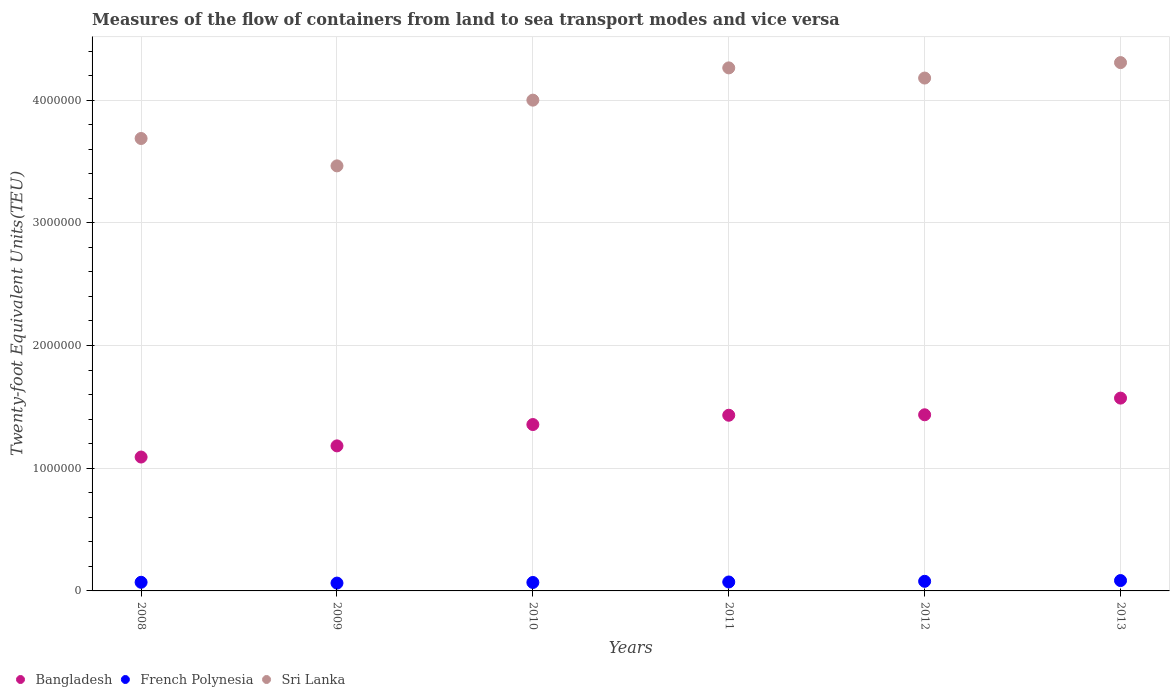What is the container port traffic in Sri Lanka in 2013?
Your answer should be compact. 4.31e+06. Across all years, what is the maximum container port traffic in French Polynesia?
Your answer should be very brief. 8.45e+04. Across all years, what is the minimum container port traffic in French Polynesia?
Make the answer very short. 6.38e+04. What is the total container port traffic in French Polynesia in the graph?
Ensure brevity in your answer.  4.39e+05. What is the difference between the container port traffic in French Polynesia in 2009 and that in 2013?
Keep it short and to the point. -2.07e+04. What is the difference between the container port traffic in French Polynesia in 2013 and the container port traffic in Bangladesh in 2010?
Offer a terse response. -1.27e+06. What is the average container port traffic in French Polynesia per year?
Ensure brevity in your answer.  7.31e+04. In the year 2012, what is the difference between the container port traffic in French Polynesia and container port traffic in Sri Lanka?
Offer a terse response. -4.10e+06. What is the ratio of the container port traffic in French Polynesia in 2008 to that in 2011?
Provide a succinct answer. 0.97. Is the difference between the container port traffic in French Polynesia in 2008 and 2013 greater than the difference between the container port traffic in Sri Lanka in 2008 and 2013?
Provide a short and direct response. Yes. What is the difference between the highest and the second highest container port traffic in French Polynesia?
Your answer should be very brief. 6183.87. What is the difference between the highest and the lowest container port traffic in French Polynesia?
Your response must be concise. 2.07e+04. In how many years, is the container port traffic in French Polynesia greater than the average container port traffic in French Polynesia taken over all years?
Offer a very short reply. 2. Is it the case that in every year, the sum of the container port traffic in French Polynesia and container port traffic in Sri Lanka  is greater than the container port traffic in Bangladesh?
Your response must be concise. Yes. Does the container port traffic in French Polynesia monotonically increase over the years?
Give a very brief answer. No. Is the container port traffic in French Polynesia strictly greater than the container port traffic in Sri Lanka over the years?
Provide a succinct answer. No. How many dotlines are there?
Ensure brevity in your answer.  3. Does the graph contain any zero values?
Your answer should be very brief. No. How many legend labels are there?
Your answer should be very brief. 3. What is the title of the graph?
Your answer should be compact. Measures of the flow of containers from land to sea transport modes and vice versa. Does "Sweden" appear as one of the legend labels in the graph?
Your answer should be compact. No. What is the label or title of the Y-axis?
Keep it short and to the point. Twenty-foot Equivalent Units(TEU). What is the Twenty-foot Equivalent Units(TEU) of Bangladesh in 2008?
Make the answer very short. 1.09e+06. What is the Twenty-foot Equivalent Units(TEU) in French Polynesia in 2008?
Offer a terse response. 7.03e+04. What is the Twenty-foot Equivalent Units(TEU) in Sri Lanka in 2008?
Make the answer very short. 3.69e+06. What is the Twenty-foot Equivalent Units(TEU) in Bangladesh in 2009?
Provide a succinct answer. 1.18e+06. What is the Twenty-foot Equivalent Units(TEU) of French Polynesia in 2009?
Keep it short and to the point. 6.38e+04. What is the Twenty-foot Equivalent Units(TEU) in Sri Lanka in 2009?
Give a very brief answer. 3.46e+06. What is the Twenty-foot Equivalent Units(TEU) in Bangladesh in 2010?
Ensure brevity in your answer.  1.36e+06. What is the Twenty-foot Equivalent Units(TEU) in French Polynesia in 2010?
Give a very brief answer. 6.89e+04. What is the Twenty-foot Equivalent Units(TEU) in Bangladesh in 2011?
Give a very brief answer. 1.43e+06. What is the Twenty-foot Equivalent Units(TEU) in French Polynesia in 2011?
Offer a very short reply. 7.28e+04. What is the Twenty-foot Equivalent Units(TEU) of Sri Lanka in 2011?
Your response must be concise. 4.26e+06. What is the Twenty-foot Equivalent Units(TEU) in Bangladesh in 2012?
Keep it short and to the point. 1.44e+06. What is the Twenty-foot Equivalent Units(TEU) in French Polynesia in 2012?
Your answer should be compact. 7.83e+04. What is the Twenty-foot Equivalent Units(TEU) in Sri Lanka in 2012?
Your response must be concise. 4.18e+06. What is the Twenty-foot Equivalent Units(TEU) of Bangladesh in 2013?
Offer a very short reply. 1.57e+06. What is the Twenty-foot Equivalent Units(TEU) in French Polynesia in 2013?
Your answer should be very brief. 8.45e+04. What is the Twenty-foot Equivalent Units(TEU) in Sri Lanka in 2013?
Your response must be concise. 4.31e+06. Across all years, what is the maximum Twenty-foot Equivalent Units(TEU) of Bangladesh?
Offer a terse response. 1.57e+06. Across all years, what is the maximum Twenty-foot Equivalent Units(TEU) of French Polynesia?
Offer a terse response. 8.45e+04. Across all years, what is the maximum Twenty-foot Equivalent Units(TEU) of Sri Lanka?
Your answer should be very brief. 4.31e+06. Across all years, what is the minimum Twenty-foot Equivalent Units(TEU) of Bangladesh?
Your answer should be very brief. 1.09e+06. Across all years, what is the minimum Twenty-foot Equivalent Units(TEU) in French Polynesia?
Your response must be concise. 6.38e+04. Across all years, what is the minimum Twenty-foot Equivalent Units(TEU) of Sri Lanka?
Your answer should be compact. 3.46e+06. What is the total Twenty-foot Equivalent Units(TEU) of Bangladesh in the graph?
Provide a succinct answer. 8.07e+06. What is the total Twenty-foot Equivalent Units(TEU) of French Polynesia in the graph?
Offer a terse response. 4.39e+05. What is the total Twenty-foot Equivalent Units(TEU) in Sri Lanka in the graph?
Ensure brevity in your answer.  2.39e+07. What is the difference between the Twenty-foot Equivalent Units(TEU) of Bangladesh in 2008 and that in 2009?
Your response must be concise. -9.09e+04. What is the difference between the Twenty-foot Equivalent Units(TEU) of French Polynesia in 2008 and that in 2009?
Make the answer very short. 6529. What is the difference between the Twenty-foot Equivalent Units(TEU) of Sri Lanka in 2008 and that in 2009?
Make the answer very short. 2.23e+05. What is the difference between the Twenty-foot Equivalent Units(TEU) in Bangladesh in 2008 and that in 2010?
Your answer should be very brief. -2.65e+05. What is the difference between the Twenty-foot Equivalent Units(TEU) in French Polynesia in 2008 and that in 2010?
Your response must be concise. 1447. What is the difference between the Twenty-foot Equivalent Units(TEU) of Sri Lanka in 2008 and that in 2010?
Your answer should be compact. -3.13e+05. What is the difference between the Twenty-foot Equivalent Units(TEU) in Bangladesh in 2008 and that in 2011?
Offer a terse response. -3.41e+05. What is the difference between the Twenty-foot Equivalent Units(TEU) of French Polynesia in 2008 and that in 2011?
Offer a terse response. -2479.67. What is the difference between the Twenty-foot Equivalent Units(TEU) of Sri Lanka in 2008 and that in 2011?
Your answer should be very brief. -5.75e+05. What is the difference between the Twenty-foot Equivalent Units(TEU) of Bangladesh in 2008 and that in 2012?
Keep it short and to the point. -3.44e+05. What is the difference between the Twenty-foot Equivalent Units(TEU) in French Polynesia in 2008 and that in 2012?
Make the answer very short. -7940.85. What is the difference between the Twenty-foot Equivalent Units(TEU) in Sri Lanka in 2008 and that in 2012?
Your response must be concise. -4.93e+05. What is the difference between the Twenty-foot Equivalent Units(TEU) in Bangladesh in 2008 and that in 2013?
Provide a short and direct response. -4.80e+05. What is the difference between the Twenty-foot Equivalent Units(TEU) of French Polynesia in 2008 and that in 2013?
Your answer should be very brief. -1.41e+04. What is the difference between the Twenty-foot Equivalent Units(TEU) in Sri Lanka in 2008 and that in 2013?
Your response must be concise. -6.19e+05. What is the difference between the Twenty-foot Equivalent Units(TEU) in Bangladesh in 2009 and that in 2010?
Make the answer very short. -1.74e+05. What is the difference between the Twenty-foot Equivalent Units(TEU) in French Polynesia in 2009 and that in 2010?
Offer a very short reply. -5082. What is the difference between the Twenty-foot Equivalent Units(TEU) in Sri Lanka in 2009 and that in 2010?
Ensure brevity in your answer.  -5.36e+05. What is the difference between the Twenty-foot Equivalent Units(TEU) of Bangladesh in 2009 and that in 2011?
Ensure brevity in your answer.  -2.50e+05. What is the difference between the Twenty-foot Equivalent Units(TEU) of French Polynesia in 2009 and that in 2011?
Your answer should be compact. -9008.67. What is the difference between the Twenty-foot Equivalent Units(TEU) in Sri Lanka in 2009 and that in 2011?
Your answer should be compact. -7.99e+05. What is the difference between the Twenty-foot Equivalent Units(TEU) in Bangladesh in 2009 and that in 2012?
Give a very brief answer. -2.53e+05. What is the difference between the Twenty-foot Equivalent Units(TEU) in French Polynesia in 2009 and that in 2012?
Offer a terse response. -1.45e+04. What is the difference between the Twenty-foot Equivalent Units(TEU) in Sri Lanka in 2009 and that in 2012?
Your response must be concise. -7.16e+05. What is the difference between the Twenty-foot Equivalent Units(TEU) of Bangladesh in 2009 and that in 2013?
Offer a terse response. -3.89e+05. What is the difference between the Twenty-foot Equivalent Units(TEU) of French Polynesia in 2009 and that in 2013?
Your answer should be compact. -2.07e+04. What is the difference between the Twenty-foot Equivalent Units(TEU) of Sri Lanka in 2009 and that in 2013?
Make the answer very short. -8.42e+05. What is the difference between the Twenty-foot Equivalent Units(TEU) in Bangladesh in 2010 and that in 2011?
Give a very brief answer. -7.58e+04. What is the difference between the Twenty-foot Equivalent Units(TEU) in French Polynesia in 2010 and that in 2011?
Offer a very short reply. -3926.67. What is the difference between the Twenty-foot Equivalent Units(TEU) of Sri Lanka in 2010 and that in 2011?
Provide a succinct answer. -2.63e+05. What is the difference between the Twenty-foot Equivalent Units(TEU) of Bangladesh in 2010 and that in 2012?
Provide a short and direct response. -7.95e+04. What is the difference between the Twenty-foot Equivalent Units(TEU) of French Polynesia in 2010 and that in 2012?
Your response must be concise. -9387.85. What is the difference between the Twenty-foot Equivalent Units(TEU) in Sri Lanka in 2010 and that in 2012?
Your answer should be very brief. -1.80e+05. What is the difference between the Twenty-foot Equivalent Units(TEU) in Bangladesh in 2010 and that in 2013?
Provide a succinct answer. -2.15e+05. What is the difference between the Twenty-foot Equivalent Units(TEU) of French Polynesia in 2010 and that in 2013?
Give a very brief answer. -1.56e+04. What is the difference between the Twenty-foot Equivalent Units(TEU) of Sri Lanka in 2010 and that in 2013?
Offer a very short reply. -3.06e+05. What is the difference between the Twenty-foot Equivalent Units(TEU) of Bangladesh in 2011 and that in 2012?
Offer a very short reply. -3748.59. What is the difference between the Twenty-foot Equivalent Units(TEU) in French Polynesia in 2011 and that in 2012?
Provide a succinct answer. -5461.18. What is the difference between the Twenty-foot Equivalent Units(TEU) in Sri Lanka in 2011 and that in 2012?
Give a very brief answer. 8.29e+04. What is the difference between the Twenty-foot Equivalent Units(TEU) of Bangladesh in 2011 and that in 2013?
Offer a terse response. -1.40e+05. What is the difference between the Twenty-foot Equivalent Units(TEU) in French Polynesia in 2011 and that in 2013?
Ensure brevity in your answer.  -1.16e+04. What is the difference between the Twenty-foot Equivalent Units(TEU) of Sri Lanka in 2011 and that in 2013?
Offer a terse response. -4.31e+04. What is the difference between the Twenty-foot Equivalent Units(TEU) in Bangladesh in 2012 and that in 2013?
Offer a very short reply. -1.36e+05. What is the difference between the Twenty-foot Equivalent Units(TEU) in French Polynesia in 2012 and that in 2013?
Provide a succinct answer. -6183.87. What is the difference between the Twenty-foot Equivalent Units(TEU) in Sri Lanka in 2012 and that in 2013?
Your answer should be very brief. -1.26e+05. What is the difference between the Twenty-foot Equivalent Units(TEU) in Bangladesh in 2008 and the Twenty-foot Equivalent Units(TEU) in French Polynesia in 2009?
Provide a succinct answer. 1.03e+06. What is the difference between the Twenty-foot Equivalent Units(TEU) in Bangladesh in 2008 and the Twenty-foot Equivalent Units(TEU) in Sri Lanka in 2009?
Give a very brief answer. -2.37e+06. What is the difference between the Twenty-foot Equivalent Units(TEU) in French Polynesia in 2008 and the Twenty-foot Equivalent Units(TEU) in Sri Lanka in 2009?
Make the answer very short. -3.39e+06. What is the difference between the Twenty-foot Equivalent Units(TEU) of Bangladesh in 2008 and the Twenty-foot Equivalent Units(TEU) of French Polynesia in 2010?
Provide a short and direct response. 1.02e+06. What is the difference between the Twenty-foot Equivalent Units(TEU) in Bangladesh in 2008 and the Twenty-foot Equivalent Units(TEU) in Sri Lanka in 2010?
Provide a succinct answer. -2.91e+06. What is the difference between the Twenty-foot Equivalent Units(TEU) of French Polynesia in 2008 and the Twenty-foot Equivalent Units(TEU) of Sri Lanka in 2010?
Your response must be concise. -3.93e+06. What is the difference between the Twenty-foot Equivalent Units(TEU) of Bangladesh in 2008 and the Twenty-foot Equivalent Units(TEU) of French Polynesia in 2011?
Provide a short and direct response. 1.02e+06. What is the difference between the Twenty-foot Equivalent Units(TEU) of Bangladesh in 2008 and the Twenty-foot Equivalent Units(TEU) of Sri Lanka in 2011?
Provide a short and direct response. -3.17e+06. What is the difference between the Twenty-foot Equivalent Units(TEU) in French Polynesia in 2008 and the Twenty-foot Equivalent Units(TEU) in Sri Lanka in 2011?
Your answer should be very brief. -4.19e+06. What is the difference between the Twenty-foot Equivalent Units(TEU) in Bangladesh in 2008 and the Twenty-foot Equivalent Units(TEU) in French Polynesia in 2012?
Your answer should be very brief. 1.01e+06. What is the difference between the Twenty-foot Equivalent Units(TEU) of Bangladesh in 2008 and the Twenty-foot Equivalent Units(TEU) of Sri Lanka in 2012?
Your response must be concise. -3.09e+06. What is the difference between the Twenty-foot Equivalent Units(TEU) in French Polynesia in 2008 and the Twenty-foot Equivalent Units(TEU) in Sri Lanka in 2012?
Provide a short and direct response. -4.11e+06. What is the difference between the Twenty-foot Equivalent Units(TEU) in Bangladesh in 2008 and the Twenty-foot Equivalent Units(TEU) in French Polynesia in 2013?
Keep it short and to the point. 1.01e+06. What is the difference between the Twenty-foot Equivalent Units(TEU) in Bangladesh in 2008 and the Twenty-foot Equivalent Units(TEU) in Sri Lanka in 2013?
Make the answer very short. -3.21e+06. What is the difference between the Twenty-foot Equivalent Units(TEU) of French Polynesia in 2008 and the Twenty-foot Equivalent Units(TEU) of Sri Lanka in 2013?
Provide a short and direct response. -4.24e+06. What is the difference between the Twenty-foot Equivalent Units(TEU) of Bangladesh in 2009 and the Twenty-foot Equivalent Units(TEU) of French Polynesia in 2010?
Provide a short and direct response. 1.11e+06. What is the difference between the Twenty-foot Equivalent Units(TEU) in Bangladesh in 2009 and the Twenty-foot Equivalent Units(TEU) in Sri Lanka in 2010?
Ensure brevity in your answer.  -2.82e+06. What is the difference between the Twenty-foot Equivalent Units(TEU) of French Polynesia in 2009 and the Twenty-foot Equivalent Units(TEU) of Sri Lanka in 2010?
Offer a terse response. -3.94e+06. What is the difference between the Twenty-foot Equivalent Units(TEU) of Bangladesh in 2009 and the Twenty-foot Equivalent Units(TEU) of French Polynesia in 2011?
Your answer should be very brief. 1.11e+06. What is the difference between the Twenty-foot Equivalent Units(TEU) in Bangladesh in 2009 and the Twenty-foot Equivalent Units(TEU) in Sri Lanka in 2011?
Provide a succinct answer. -3.08e+06. What is the difference between the Twenty-foot Equivalent Units(TEU) of French Polynesia in 2009 and the Twenty-foot Equivalent Units(TEU) of Sri Lanka in 2011?
Offer a terse response. -4.20e+06. What is the difference between the Twenty-foot Equivalent Units(TEU) of Bangladesh in 2009 and the Twenty-foot Equivalent Units(TEU) of French Polynesia in 2012?
Offer a very short reply. 1.10e+06. What is the difference between the Twenty-foot Equivalent Units(TEU) of Bangladesh in 2009 and the Twenty-foot Equivalent Units(TEU) of Sri Lanka in 2012?
Provide a succinct answer. -3.00e+06. What is the difference between the Twenty-foot Equivalent Units(TEU) in French Polynesia in 2009 and the Twenty-foot Equivalent Units(TEU) in Sri Lanka in 2012?
Your answer should be very brief. -4.12e+06. What is the difference between the Twenty-foot Equivalent Units(TEU) in Bangladesh in 2009 and the Twenty-foot Equivalent Units(TEU) in French Polynesia in 2013?
Keep it short and to the point. 1.10e+06. What is the difference between the Twenty-foot Equivalent Units(TEU) of Bangladesh in 2009 and the Twenty-foot Equivalent Units(TEU) of Sri Lanka in 2013?
Provide a short and direct response. -3.12e+06. What is the difference between the Twenty-foot Equivalent Units(TEU) of French Polynesia in 2009 and the Twenty-foot Equivalent Units(TEU) of Sri Lanka in 2013?
Give a very brief answer. -4.24e+06. What is the difference between the Twenty-foot Equivalent Units(TEU) in Bangladesh in 2010 and the Twenty-foot Equivalent Units(TEU) in French Polynesia in 2011?
Ensure brevity in your answer.  1.28e+06. What is the difference between the Twenty-foot Equivalent Units(TEU) of Bangladesh in 2010 and the Twenty-foot Equivalent Units(TEU) of Sri Lanka in 2011?
Give a very brief answer. -2.91e+06. What is the difference between the Twenty-foot Equivalent Units(TEU) in French Polynesia in 2010 and the Twenty-foot Equivalent Units(TEU) in Sri Lanka in 2011?
Your answer should be compact. -4.19e+06. What is the difference between the Twenty-foot Equivalent Units(TEU) in Bangladesh in 2010 and the Twenty-foot Equivalent Units(TEU) in French Polynesia in 2012?
Your answer should be very brief. 1.28e+06. What is the difference between the Twenty-foot Equivalent Units(TEU) of Bangladesh in 2010 and the Twenty-foot Equivalent Units(TEU) of Sri Lanka in 2012?
Offer a very short reply. -2.82e+06. What is the difference between the Twenty-foot Equivalent Units(TEU) of French Polynesia in 2010 and the Twenty-foot Equivalent Units(TEU) of Sri Lanka in 2012?
Ensure brevity in your answer.  -4.11e+06. What is the difference between the Twenty-foot Equivalent Units(TEU) in Bangladesh in 2010 and the Twenty-foot Equivalent Units(TEU) in French Polynesia in 2013?
Provide a succinct answer. 1.27e+06. What is the difference between the Twenty-foot Equivalent Units(TEU) of Bangladesh in 2010 and the Twenty-foot Equivalent Units(TEU) of Sri Lanka in 2013?
Your response must be concise. -2.95e+06. What is the difference between the Twenty-foot Equivalent Units(TEU) in French Polynesia in 2010 and the Twenty-foot Equivalent Units(TEU) in Sri Lanka in 2013?
Give a very brief answer. -4.24e+06. What is the difference between the Twenty-foot Equivalent Units(TEU) in Bangladesh in 2011 and the Twenty-foot Equivalent Units(TEU) in French Polynesia in 2012?
Offer a very short reply. 1.35e+06. What is the difference between the Twenty-foot Equivalent Units(TEU) of Bangladesh in 2011 and the Twenty-foot Equivalent Units(TEU) of Sri Lanka in 2012?
Provide a succinct answer. -2.75e+06. What is the difference between the Twenty-foot Equivalent Units(TEU) in French Polynesia in 2011 and the Twenty-foot Equivalent Units(TEU) in Sri Lanka in 2012?
Your answer should be compact. -4.11e+06. What is the difference between the Twenty-foot Equivalent Units(TEU) of Bangladesh in 2011 and the Twenty-foot Equivalent Units(TEU) of French Polynesia in 2013?
Provide a short and direct response. 1.35e+06. What is the difference between the Twenty-foot Equivalent Units(TEU) in Bangladesh in 2011 and the Twenty-foot Equivalent Units(TEU) in Sri Lanka in 2013?
Make the answer very short. -2.87e+06. What is the difference between the Twenty-foot Equivalent Units(TEU) of French Polynesia in 2011 and the Twenty-foot Equivalent Units(TEU) of Sri Lanka in 2013?
Ensure brevity in your answer.  -4.23e+06. What is the difference between the Twenty-foot Equivalent Units(TEU) of Bangladesh in 2012 and the Twenty-foot Equivalent Units(TEU) of French Polynesia in 2013?
Your response must be concise. 1.35e+06. What is the difference between the Twenty-foot Equivalent Units(TEU) in Bangladesh in 2012 and the Twenty-foot Equivalent Units(TEU) in Sri Lanka in 2013?
Your response must be concise. -2.87e+06. What is the difference between the Twenty-foot Equivalent Units(TEU) in French Polynesia in 2012 and the Twenty-foot Equivalent Units(TEU) in Sri Lanka in 2013?
Keep it short and to the point. -4.23e+06. What is the average Twenty-foot Equivalent Units(TEU) in Bangladesh per year?
Offer a terse response. 1.34e+06. What is the average Twenty-foot Equivalent Units(TEU) in French Polynesia per year?
Ensure brevity in your answer.  7.31e+04. What is the average Twenty-foot Equivalent Units(TEU) of Sri Lanka per year?
Offer a very short reply. 3.98e+06. In the year 2008, what is the difference between the Twenty-foot Equivalent Units(TEU) of Bangladesh and Twenty-foot Equivalent Units(TEU) of French Polynesia?
Provide a short and direct response. 1.02e+06. In the year 2008, what is the difference between the Twenty-foot Equivalent Units(TEU) of Bangladesh and Twenty-foot Equivalent Units(TEU) of Sri Lanka?
Ensure brevity in your answer.  -2.60e+06. In the year 2008, what is the difference between the Twenty-foot Equivalent Units(TEU) in French Polynesia and Twenty-foot Equivalent Units(TEU) in Sri Lanka?
Make the answer very short. -3.62e+06. In the year 2009, what is the difference between the Twenty-foot Equivalent Units(TEU) of Bangladesh and Twenty-foot Equivalent Units(TEU) of French Polynesia?
Provide a succinct answer. 1.12e+06. In the year 2009, what is the difference between the Twenty-foot Equivalent Units(TEU) in Bangladesh and Twenty-foot Equivalent Units(TEU) in Sri Lanka?
Your response must be concise. -2.28e+06. In the year 2009, what is the difference between the Twenty-foot Equivalent Units(TEU) in French Polynesia and Twenty-foot Equivalent Units(TEU) in Sri Lanka?
Give a very brief answer. -3.40e+06. In the year 2010, what is the difference between the Twenty-foot Equivalent Units(TEU) of Bangladesh and Twenty-foot Equivalent Units(TEU) of French Polynesia?
Offer a very short reply. 1.29e+06. In the year 2010, what is the difference between the Twenty-foot Equivalent Units(TEU) of Bangladesh and Twenty-foot Equivalent Units(TEU) of Sri Lanka?
Provide a short and direct response. -2.64e+06. In the year 2010, what is the difference between the Twenty-foot Equivalent Units(TEU) of French Polynesia and Twenty-foot Equivalent Units(TEU) of Sri Lanka?
Give a very brief answer. -3.93e+06. In the year 2011, what is the difference between the Twenty-foot Equivalent Units(TEU) of Bangladesh and Twenty-foot Equivalent Units(TEU) of French Polynesia?
Make the answer very short. 1.36e+06. In the year 2011, what is the difference between the Twenty-foot Equivalent Units(TEU) of Bangladesh and Twenty-foot Equivalent Units(TEU) of Sri Lanka?
Give a very brief answer. -2.83e+06. In the year 2011, what is the difference between the Twenty-foot Equivalent Units(TEU) in French Polynesia and Twenty-foot Equivalent Units(TEU) in Sri Lanka?
Provide a succinct answer. -4.19e+06. In the year 2012, what is the difference between the Twenty-foot Equivalent Units(TEU) of Bangladesh and Twenty-foot Equivalent Units(TEU) of French Polynesia?
Offer a very short reply. 1.36e+06. In the year 2012, what is the difference between the Twenty-foot Equivalent Units(TEU) in Bangladesh and Twenty-foot Equivalent Units(TEU) in Sri Lanka?
Your answer should be compact. -2.74e+06. In the year 2012, what is the difference between the Twenty-foot Equivalent Units(TEU) in French Polynesia and Twenty-foot Equivalent Units(TEU) in Sri Lanka?
Offer a terse response. -4.10e+06. In the year 2013, what is the difference between the Twenty-foot Equivalent Units(TEU) in Bangladesh and Twenty-foot Equivalent Units(TEU) in French Polynesia?
Make the answer very short. 1.49e+06. In the year 2013, what is the difference between the Twenty-foot Equivalent Units(TEU) of Bangladesh and Twenty-foot Equivalent Units(TEU) of Sri Lanka?
Offer a terse response. -2.73e+06. In the year 2013, what is the difference between the Twenty-foot Equivalent Units(TEU) of French Polynesia and Twenty-foot Equivalent Units(TEU) of Sri Lanka?
Provide a succinct answer. -4.22e+06. What is the ratio of the Twenty-foot Equivalent Units(TEU) of Bangladesh in 2008 to that in 2009?
Make the answer very short. 0.92. What is the ratio of the Twenty-foot Equivalent Units(TEU) of French Polynesia in 2008 to that in 2009?
Your answer should be compact. 1.1. What is the ratio of the Twenty-foot Equivalent Units(TEU) in Sri Lanka in 2008 to that in 2009?
Offer a very short reply. 1.06. What is the ratio of the Twenty-foot Equivalent Units(TEU) of Bangladesh in 2008 to that in 2010?
Your answer should be very brief. 0.8. What is the ratio of the Twenty-foot Equivalent Units(TEU) in Sri Lanka in 2008 to that in 2010?
Provide a short and direct response. 0.92. What is the ratio of the Twenty-foot Equivalent Units(TEU) in Bangladesh in 2008 to that in 2011?
Offer a very short reply. 0.76. What is the ratio of the Twenty-foot Equivalent Units(TEU) of French Polynesia in 2008 to that in 2011?
Keep it short and to the point. 0.97. What is the ratio of the Twenty-foot Equivalent Units(TEU) of Sri Lanka in 2008 to that in 2011?
Provide a succinct answer. 0.86. What is the ratio of the Twenty-foot Equivalent Units(TEU) in Bangladesh in 2008 to that in 2012?
Offer a terse response. 0.76. What is the ratio of the Twenty-foot Equivalent Units(TEU) of French Polynesia in 2008 to that in 2012?
Provide a succinct answer. 0.9. What is the ratio of the Twenty-foot Equivalent Units(TEU) in Sri Lanka in 2008 to that in 2012?
Keep it short and to the point. 0.88. What is the ratio of the Twenty-foot Equivalent Units(TEU) of Bangladesh in 2008 to that in 2013?
Offer a terse response. 0.69. What is the ratio of the Twenty-foot Equivalent Units(TEU) of French Polynesia in 2008 to that in 2013?
Give a very brief answer. 0.83. What is the ratio of the Twenty-foot Equivalent Units(TEU) in Sri Lanka in 2008 to that in 2013?
Provide a short and direct response. 0.86. What is the ratio of the Twenty-foot Equivalent Units(TEU) in Bangladesh in 2009 to that in 2010?
Make the answer very short. 0.87. What is the ratio of the Twenty-foot Equivalent Units(TEU) of French Polynesia in 2009 to that in 2010?
Your answer should be very brief. 0.93. What is the ratio of the Twenty-foot Equivalent Units(TEU) of Sri Lanka in 2009 to that in 2010?
Keep it short and to the point. 0.87. What is the ratio of the Twenty-foot Equivalent Units(TEU) in Bangladesh in 2009 to that in 2011?
Keep it short and to the point. 0.83. What is the ratio of the Twenty-foot Equivalent Units(TEU) in French Polynesia in 2009 to that in 2011?
Provide a short and direct response. 0.88. What is the ratio of the Twenty-foot Equivalent Units(TEU) in Sri Lanka in 2009 to that in 2011?
Your response must be concise. 0.81. What is the ratio of the Twenty-foot Equivalent Units(TEU) of Bangladesh in 2009 to that in 2012?
Offer a very short reply. 0.82. What is the ratio of the Twenty-foot Equivalent Units(TEU) in French Polynesia in 2009 to that in 2012?
Offer a terse response. 0.82. What is the ratio of the Twenty-foot Equivalent Units(TEU) of Sri Lanka in 2009 to that in 2012?
Provide a short and direct response. 0.83. What is the ratio of the Twenty-foot Equivalent Units(TEU) of Bangladesh in 2009 to that in 2013?
Your answer should be very brief. 0.75. What is the ratio of the Twenty-foot Equivalent Units(TEU) in French Polynesia in 2009 to that in 2013?
Your answer should be compact. 0.76. What is the ratio of the Twenty-foot Equivalent Units(TEU) of Sri Lanka in 2009 to that in 2013?
Provide a succinct answer. 0.8. What is the ratio of the Twenty-foot Equivalent Units(TEU) of Bangladesh in 2010 to that in 2011?
Make the answer very short. 0.95. What is the ratio of the Twenty-foot Equivalent Units(TEU) in French Polynesia in 2010 to that in 2011?
Give a very brief answer. 0.95. What is the ratio of the Twenty-foot Equivalent Units(TEU) of Sri Lanka in 2010 to that in 2011?
Ensure brevity in your answer.  0.94. What is the ratio of the Twenty-foot Equivalent Units(TEU) of Bangladesh in 2010 to that in 2012?
Keep it short and to the point. 0.94. What is the ratio of the Twenty-foot Equivalent Units(TEU) in French Polynesia in 2010 to that in 2012?
Your response must be concise. 0.88. What is the ratio of the Twenty-foot Equivalent Units(TEU) of Sri Lanka in 2010 to that in 2012?
Your response must be concise. 0.96. What is the ratio of the Twenty-foot Equivalent Units(TEU) of Bangladesh in 2010 to that in 2013?
Offer a very short reply. 0.86. What is the ratio of the Twenty-foot Equivalent Units(TEU) of French Polynesia in 2010 to that in 2013?
Your response must be concise. 0.82. What is the ratio of the Twenty-foot Equivalent Units(TEU) of Sri Lanka in 2010 to that in 2013?
Your answer should be compact. 0.93. What is the ratio of the Twenty-foot Equivalent Units(TEU) of French Polynesia in 2011 to that in 2012?
Provide a short and direct response. 0.93. What is the ratio of the Twenty-foot Equivalent Units(TEU) of Sri Lanka in 2011 to that in 2012?
Your answer should be compact. 1.02. What is the ratio of the Twenty-foot Equivalent Units(TEU) in Bangladesh in 2011 to that in 2013?
Provide a short and direct response. 0.91. What is the ratio of the Twenty-foot Equivalent Units(TEU) in French Polynesia in 2011 to that in 2013?
Your answer should be compact. 0.86. What is the ratio of the Twenty-foot Equivalent Units(TEU) of Sri Lanka in 2011 to that in 2013?
Your response must be concise. 0.99. What is the ratio of the Twenty-foot Equivalent Units(TEU) of Bangladesh in 2012 to that in 2013?
Your answer should be very brief. 0.91. What is the ratio of the Twenty-foot Equivalent Units(TEU) in French Polynesia in 2012 to that in 2013?
Provide a short and direct response. 0.93. What is the ratio of the Twenty-foot Equivalent Units(TEU) in Sri Lanka in 2012 to that in 2013?
Offer a very short reply. 0.97. What is the difference between the highest and the second highest Twenty-foot Equivalent Units(TEU) of Bangladesh?
Give a very brief answer. 1.36e+05. What is the difference between the highest and the second highest Twenty-foot Equivalent Units(TEU) of French Polynesia?
Offer a terse response. 6183.87. What is the difference between the highest and the second highest Twenty-foot Equivalent Units(TEU) in Sri Lanka?
Your response must be concise. 4.31e+04. What is the difference between the highest and the lowest Twenty-foot Equivalent Units(TEU) in Bangladesh?
Your answer should be compact. 4.80e+05. What is the difference between the highest and the lowest Twenty-foot Equivalent Units(TEU) in French Polynesia?
Provide a short and direct response. 2.07e+04. What is the difference between the highest and the lowest Twenty-foot Equivalent Units(TEU) in Sri Lanka?
Give a very brief answer. 8.42e+05. 